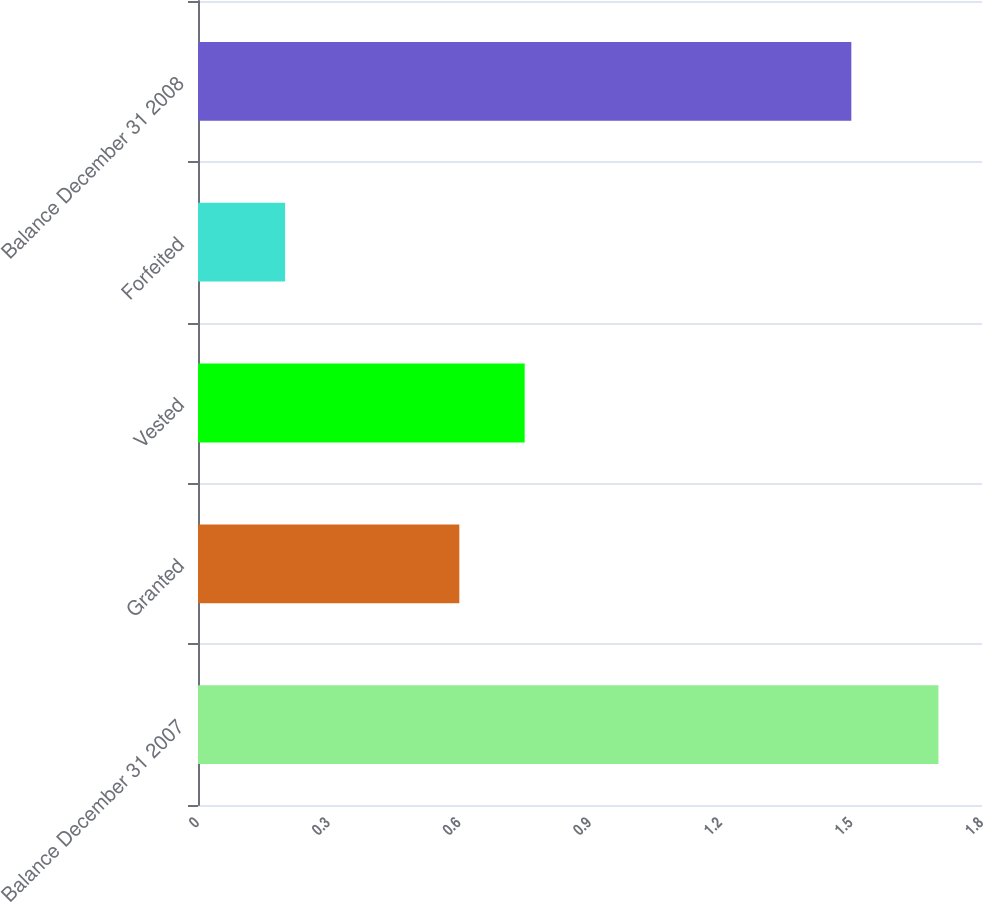Convert chart. <chart><loc_0><loc_0><loc_500><loc_500><bar_chart><fcel>Balance December 31 2007<fcel>Granted<fcel>Vested<fcel>Forfeited<fcel>Balance December 31 2008<nl><fcel>1.7<fcel>0.6<fcel>0.75<fcel>0.2<fcel>1.5<nl></chart> 